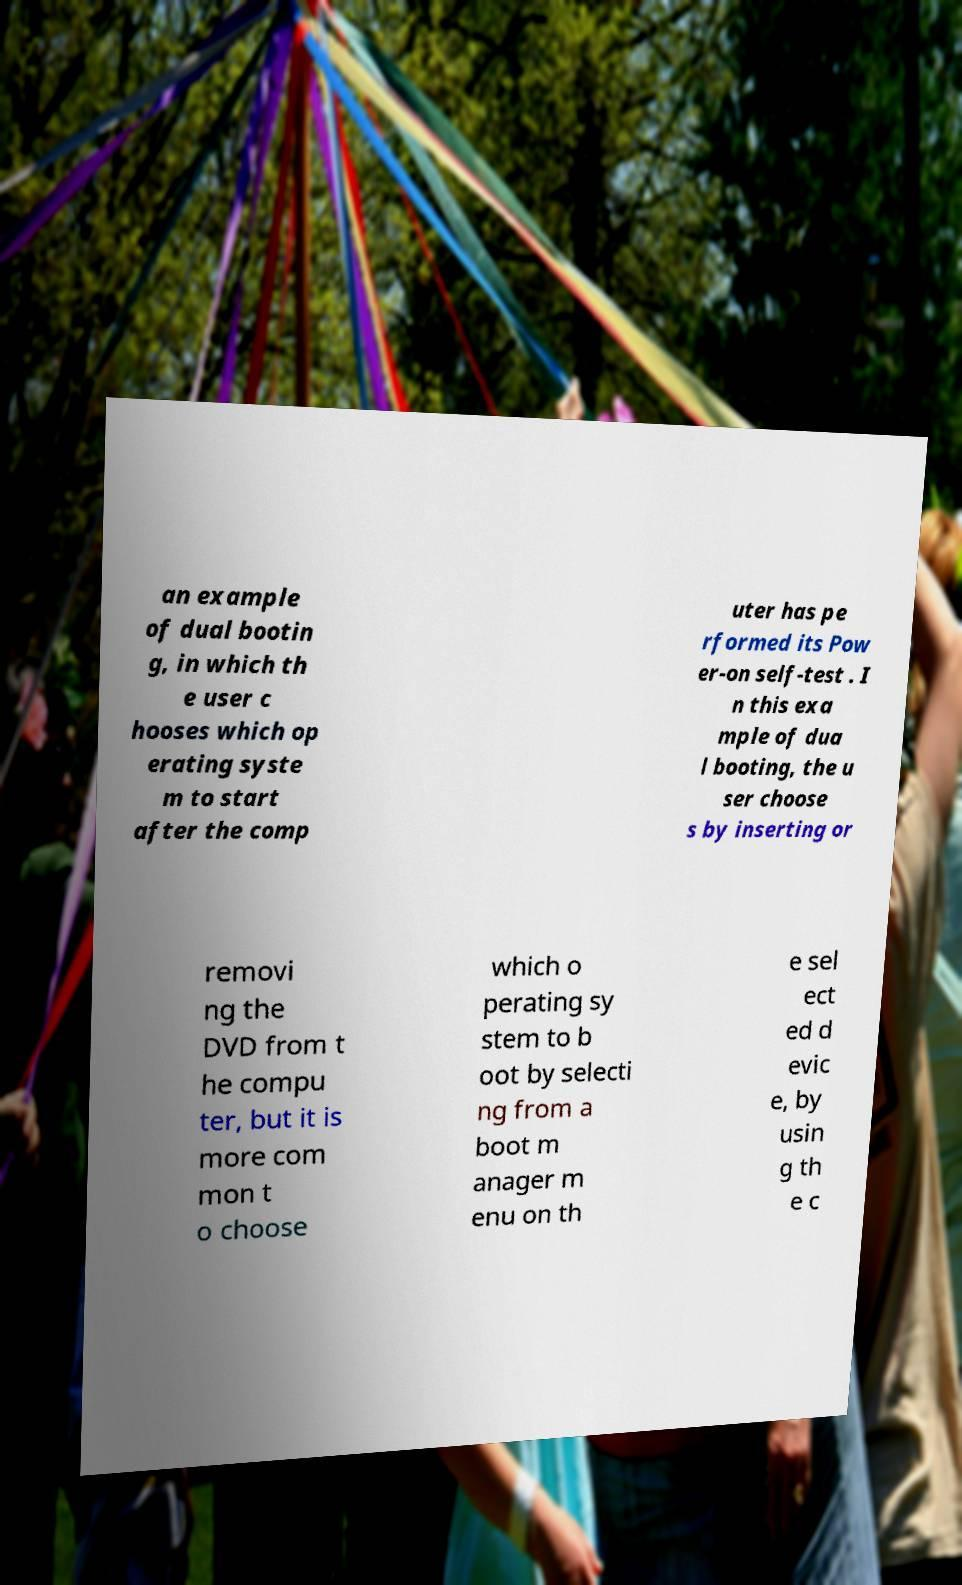Could you assist in decoding the text presented in this image and type it out clearly? an example of dual bootin g, in which th e user c hooses which op erating syste m to start after the comp uter has pe rformed its Pow er-on self-test . I n this exa mple of dua l booting, the u ser choose s by inserting or removi ng the DVD from t he compu ter, but it is more com mon t o choose which o perating sy stem to b oot by selecti ng from a boot m anager m enu on th e sel ect ed d evic e, by usin g th e c 